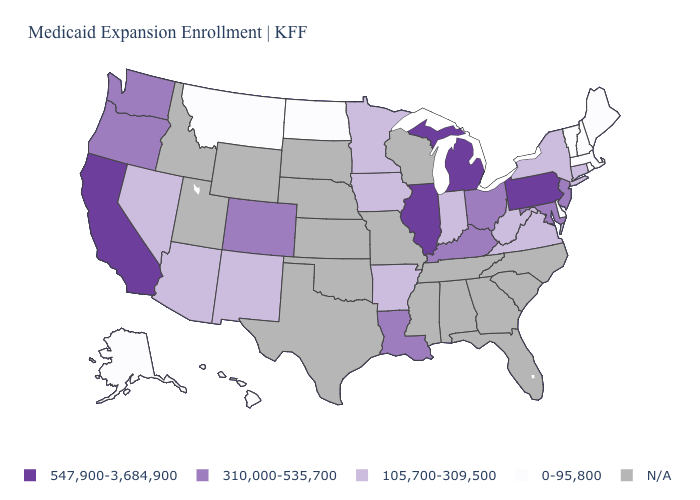What is the value of Indiana?
Write a very short answer. 105,700-309,500. What is the value of New York?
Be succinct. 105,700-309,500. Does Hawaii have the lowest value in the USA?
Keep it brief. Yes. What is the value of Illinois?
Give a very brief answer. 547,900-3,684,900. Name the states that have a value in the range N/A?
Write a very short answer. Alabama, Florida, Georgia, Idaho, Kansas, Mississippi, Missouri, Nebraska, North Carolina, Oklahoma, South Carolina, South Dakota, Tennessee, Texas, Utah, Wisconsin, Wyoming. What is the highest value in states that border New Mexico?
Short answer required. 310,000-535,700. What is the value of Pennsylvania?
Answer briefly. 547,900-3,684,900. What is the value of Pennsylvania?
Quick response, please. 547,900-3,684,900. Does Colorado have the lowest value in the West?
Be succinct. No. What is the value of Massachusetts?
Short answer required. 0-95,800. What is the value of New Jersey?
Keep it brief. 310,000-535,700. Does California have the highest value in the West?
Be succinct. Yes. Name the states that have a value in the range 310,000-535,700?
Quick response, please. Colorado, Kentucky, Louisiana, Maryland, New Jersey, Ohio, Oregon, Washington. What is the value of Minnesota?
Be succinct. 105,700-309,500. 